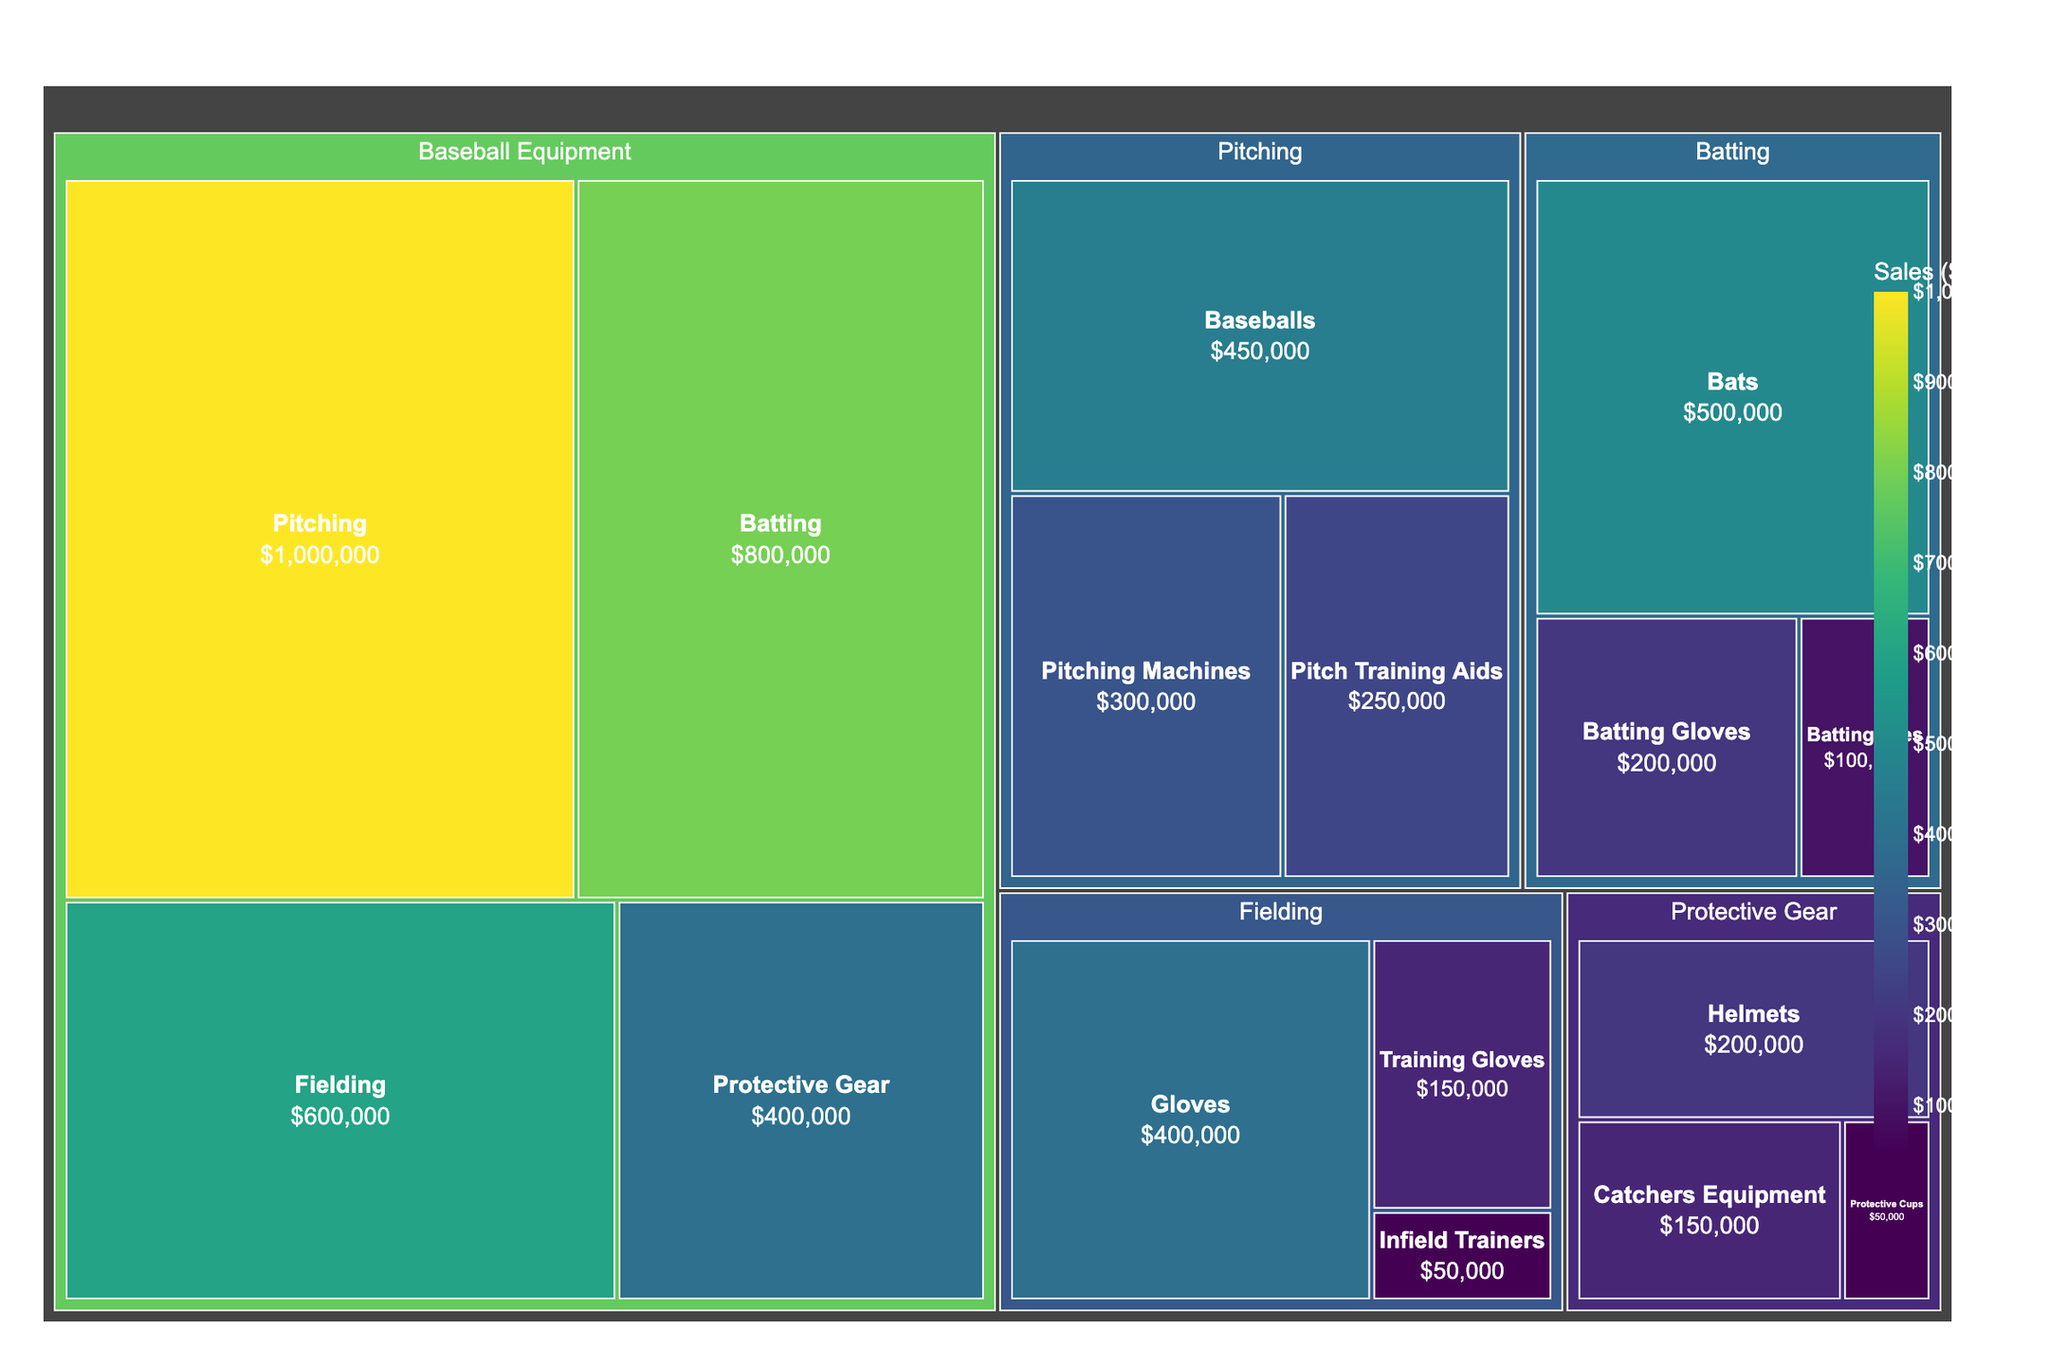Who has the highest sales in the "Pitching" subcategory? Look at the "Pitching" section and find the largest sales value. The largest sales value is $450,000 for "Baseballs".
Answer: Baseballs How much more were the sales for "Bats" compared to "Pitching Machines"? Identify the sales for "Bats" ($500,000) and "Pitching Machines" ($300,000), then subtract the latter from the former: 500,000 - 300,000 = 200,000.
Answer: $200,000 Which category within "Baseball Equipment" has the lowest sales and what is the value? Compare the sales values of "Pitching" ($1,000,000), "Batting" ($800,000), "Fielding" ($600,000), and "Protective Gear" ($400,000). The lowest is "Protective Gear" with $400,000.
Answer: Protective Gear, $400,000 What are the combined sales of "Protective Gear" and "Fielding" subcategories? Add the sales values of "Protective Gear" ($400,000) and "Fielding" ($600,000): 400,000 + 600,000 = 1,000,000.
Answer: $1,000,000 Which has higher sales: "Pitch Training Aids" or "Batting Gloves"? Compare the sales values of "Pitch Training Aids" ($250,000) and "Batting Gloves" ($200,000). "Pitch Training Aids" is higher.
Answer: Pitch Training Aids What is the average sales value within the "Protective Gear" subcategory? Sum the sales of "Helmets" ($200,000), "Catchers Equipment" ($150,000), and "Protective Cups" ($50,000) to get 400,000. Divide by the number of items (3): 400,000 / 3 = 133,333.33.
Answer: $133,333.33 Which subcategory in "Batting" has the smallest contribution to its total sales? Compare the sales values of "Bats" ($500,000), "Batting Gloves" ($200,000), and "Batting Tees" ($100,000). The smallest is "Batting Tees" with $100,000.
Answer: Batting Tees What percentage of total sales does the "Fielding" category represent? Total sales is the sum of "Pitching" ($1,000,000), "Batting" ($800,000), "Fielding" ($600,000), and "Protective Gear" ($400,000) = 2,800,000. The share of "Fielding" is 600,000 / 2,800,000 * 100% = 21.43%.
Answer: 21.43% How do the sales of "Helmets" compare to "Gloves"? Compare the sales values of "Helmets" ($200,000) and "Gloves" ($400,000). "Gloves" has higher sales.
Answer: Gloves If 10% of "Pitching Machines" sales were additional revenue, what would be the new total sales for this subcategory? Calculate 10% of "Pitching Machines" sales: 300,000 * 0.1 = 30,000. Add this to the original "Pitching Machines" sales: 300,000 + 30,000 = 330,000.
Answer: $330,000 